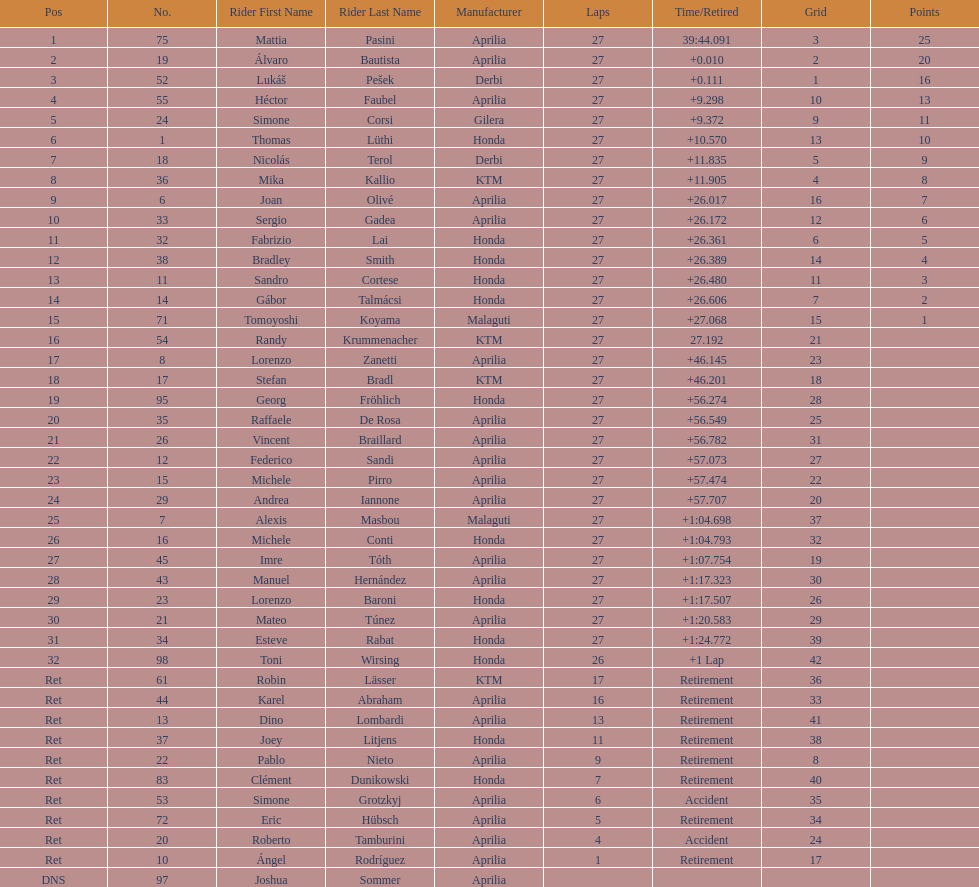I'm looking to parse the entire table for insights. Could you assist me with that? {'header': ['Pos', 'No.', 'Rider First Name', 'Rider Last Name', 'Manufacturer', 'Laps', 'Time/Retired', 'Grid', 'Points'], 'rows': [['1', '75', 'Mattia', 'Pasini', 'Aprilia', '27', '39:44.091', '3', '25'], ['2', '19', 'Álvaro', 'Bautista', 'Aprilia', '27', '+0.010', '2', '20'], ['3', '52', 'Lukáš', 'Pešek', 'Derbi', '27', '+0.111', '1', '16'], ['4', '55', 'Héctor', 'Faubel', 'Aprilia', '27', '+9.298', '10', '13'], ['5', '24', 'Simone', 'Corsi', 'Gilera', '27', '+9.372', '9', '11'], ['6', '1', 'Thomas', 'Lüthi', 'Honda', '27', '+10.570', '13', '10'], ['7', '18', 'Nicolás', 'Terol', 'Derbi', '27', '+11.835', '5', '9'], ['8', '36', 'Mika', 'Kallio', 'KTM', '27', '+11.905', '4', '8'], ['9', '6', 'Joan', 'Olivé', 'Aprilia', '27', '+26.017', '16', '7'], ['10', '33', 'Sergio', 'Gadea', 'Aprilia', '27', '+26.172', '12', '6'], ['11', '32', 'Fabrizio', 'Lai', 'Honda', '27', '+26.361', '6', '5'], ['12', '38', 'Bradley', 'Smith', 'Honda', '27', '+26.389', '14', '4'], ['13', '11', 'Sandro', 'Cortese', 'Honda', '27', '+26.480', '11', '3'], ['14', '14', 'Gábor', 'Talmácsi', 'Honda', '27', '+26.606', '7', '2'], ['15', '71', 'Tomoyoshi', 'Koyama', 'Malaguti', '27', '+27.068', '15', '1'], ['16', '54', 'Randy', 'Krummenacher', 'KTM', '27', '27.192', '21', ''], ['17', '8', 'Lorenzo', 'Zanetti', 'Aprilia', '27', '+46.145', '23', ''], ['18', '17', 'Stefan', 'Bradl', 'KTM', '27', '+46.201', '18', ''], ['19', '95', 'Georg', 'Fröhlich', 'Honda', '27', '+56.274', '28', ''], ['20', '35', 'Raffaele', 'De Rosa', 'Aprilia', '27', '+56.549', '25', ''], ['21', '26', 'Vincent', 'Braillard', 'Aprilia', '27', '+56.782', '31', ''], ['22', '12', 'Federico', 'Sandi', 'Aprilia', '27', '+57.073', '27', ''], ['23', '15', 'Michele', 'Pirro', 'Aprilia', '27', '+57.474', '22', ''], ['24', '29', 'Andrea', 'Iannone', 'Aprilia', '27', '+57.707', '20', ''], ['25', '7', 'Alexis', 'Masbou', 'Malaguti', '27', '+1:04.698', '37', ''], ['26', '16', 'Michele', 'Conti', 'Honda', '27', '+1:04.793', '32', ''], ['27', '45', 'Imre', 'Tóth', 'Aprilia', '27', '+1:07.754', '19', ''], ['28', '43', 'Manuel', 'Hernández', 'Aprilia', '27', '+1:17.323', '30', ''], ['29', '23', 'Lorenzo', 'Baroni', 'Honda', '27', '+1:17.507', '26', ''], ['30', '21', 'Mateo', 'Túnez', 'Aprilia', '27', '+1:20.583', '29', ''], ['31', '34', 'Esteve', 'Rabat', 'Honda', '27', '+1:24.772', '39', ''], ['32', '98', 'Toni', 'Wirsing', 'Honda', '26', '+1 Lap', '42', ''], ['Ret', '61', 'Robin', 'Lässer', 'KTM', '17', 'Retirement', '36', ''], ['Ret', '44', 'Karel', 'Abraham', 'Aprilia', '16', 'Retirement', '33', ''], ['Ret', '13', 'Dino', 'Lombardi', 'Aprilia', '13', 'Retirement', '41', ''], ['Ret', '37', 'Joey', 'Litjens', 'Honda', '11', 'Retirement', '38', ''], ['Ret', '22', 'Pablo', 'Nieto', 'Aprilia', '9', 'Retirement', '8', ''], ['Ret', '83', 'Clément', 'Dunikowski', 'Honda', '7', 'Retirement', '40', ''], ['Ret', '53', 'Simone', 'Grotzkyj', 'Aprilia', '6', 'Accident', '35', ''], ['Ret', '72', 'Eric', 'Hübsch', 'Aprilia', '5', 'Retirement', '34', ''], ['Ret', '20', 'Roberto', 'Tamburini', 'Aprilia', '4', 'Accident', '24', ''], ['Ret', '10', 'Ángel', 'Rodríguez', 'Aprilia', '1', 'Retirement', '17', ''], ['DNS', '97', 'Joshua', 'Sommer', 'Aprilia', '', '', '', '']]} How many racers did not use an aprilia or a honda? 9. 